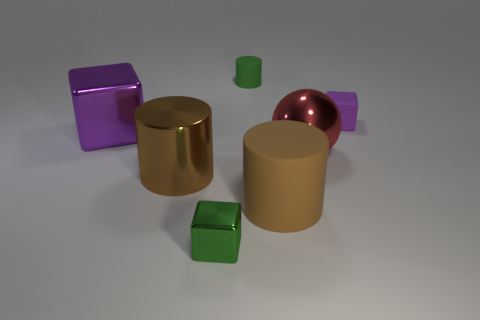Do the brown metal object and the brown matte thing have the same shape?
Provide a short and direct response. Yes. Is there any other thing that has the same shape as the purple rubber thing?
Offer a terse response. Yes. There is a purple rubber object; is its shape the same as the object in front of the big brown matte cylinder?
Offer a very short reply. Yes. Do the large cylinder left of the tiny metal cube and the large cylinder on the right side of the brown shiny cylinder have the same color?
Offer a very short reply. Yes. What size is the other rubber thing that is the same shape as the brown matte thing?
Provide a succinct answer. Small. What is the material of the big thing that is the same color as the tiny matte cube?
Offer a terse response. Metal. What shape is the brown metal thing that is the same size as the metallic sphere?
Your answer should be compact. Cylinder. Is there a small red object that has the same shape as the big brown metallic thing?
Keep it short and to the point. No. Is the number of small cubes less than the number of small cylinders?
Offer a terse response. No. Do the rubber cylinder that is in front of the big red shiny object and the red object to the right of the green metallic cube have the same size?
Your answer should be very brief. Yes. 